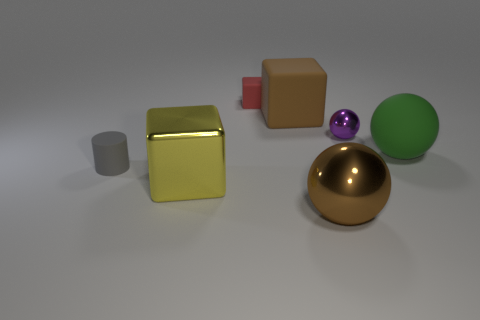Is there any indication of the size of these objects? Without a standard object for scale, it's difficult to determine the exact size of these objects. However, based on the image, they appear to be similar in size to what you might find on a typical desk or table – small enough to be handled comfortably in one's hands. 